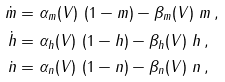Convert formula to latex. <formula><loc_0><loc_0><loc_500><loc_500>\dot { m } & = \alpha _ { m } ( V ) \ ( 1 - m ) - \beta _ { m } ( V ) \ m \, , \\ \dot { h } & = \alpha _ { h } ( V ) \ ( 1 - h ) - \beta _ { h } ( V ) \ h \, , \\ \dot { n } & = \alpha _ { n } ( V ) \ ( 1 - n ) - \beta _ { n } ( V ) \ n \, ,</formula> 